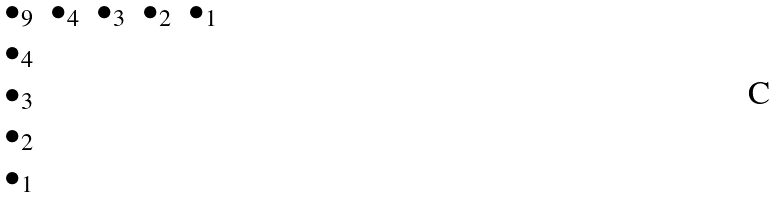Convert formula to latex. <formula><loc_0><loc_0><loc_500><loc_500>\begin{matrix} \bullet _ { 9 } & \bullet _ { 4 } & \bullet _ { 3 } & \bullet _ { 2 } & \bullet _ { 1 } \\ \bullet _ { 4 } \\ \bullet _ { 3 } \\ \bullet _ { 2 } \\ \bullet _ { 1 } \end{matrix}</formula> 